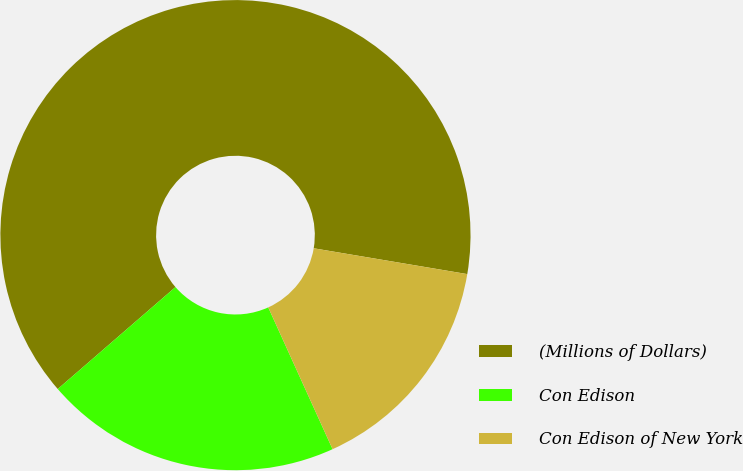Convert chart. <chart><loc_0><loc_0><loc_500><loc_500><pie_chart><fcel>(Millions of Dollars)<fcel>Con Edison<fcel>Con Edison of New York<nl><fcel>64.01%<fcel>20.42%<fcel>15.57%<nl></chart> 